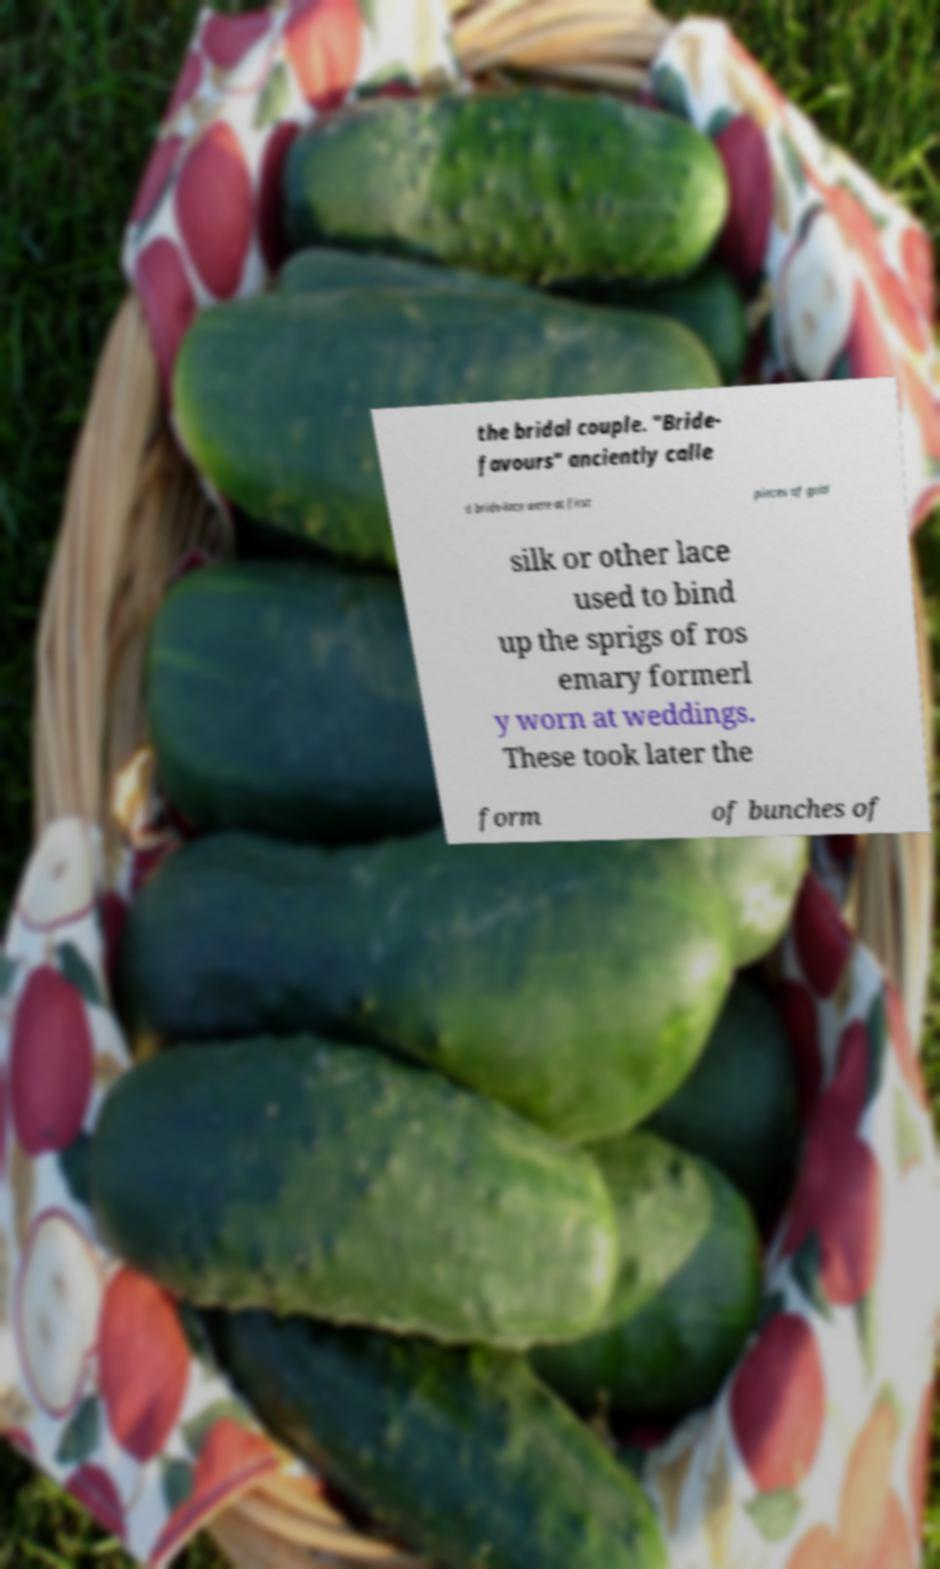Can you read and provide the text displayed in the image?This photo seems to have some interesting text. Can you extract and type it out for me? the bridal couple. "Bride- favours" anciently calle d bride-lace were at first pieces of gold silk or other lace used to bind up the sprigs of ros emary formerl y worn at weddings. These took later the form of bunches of 